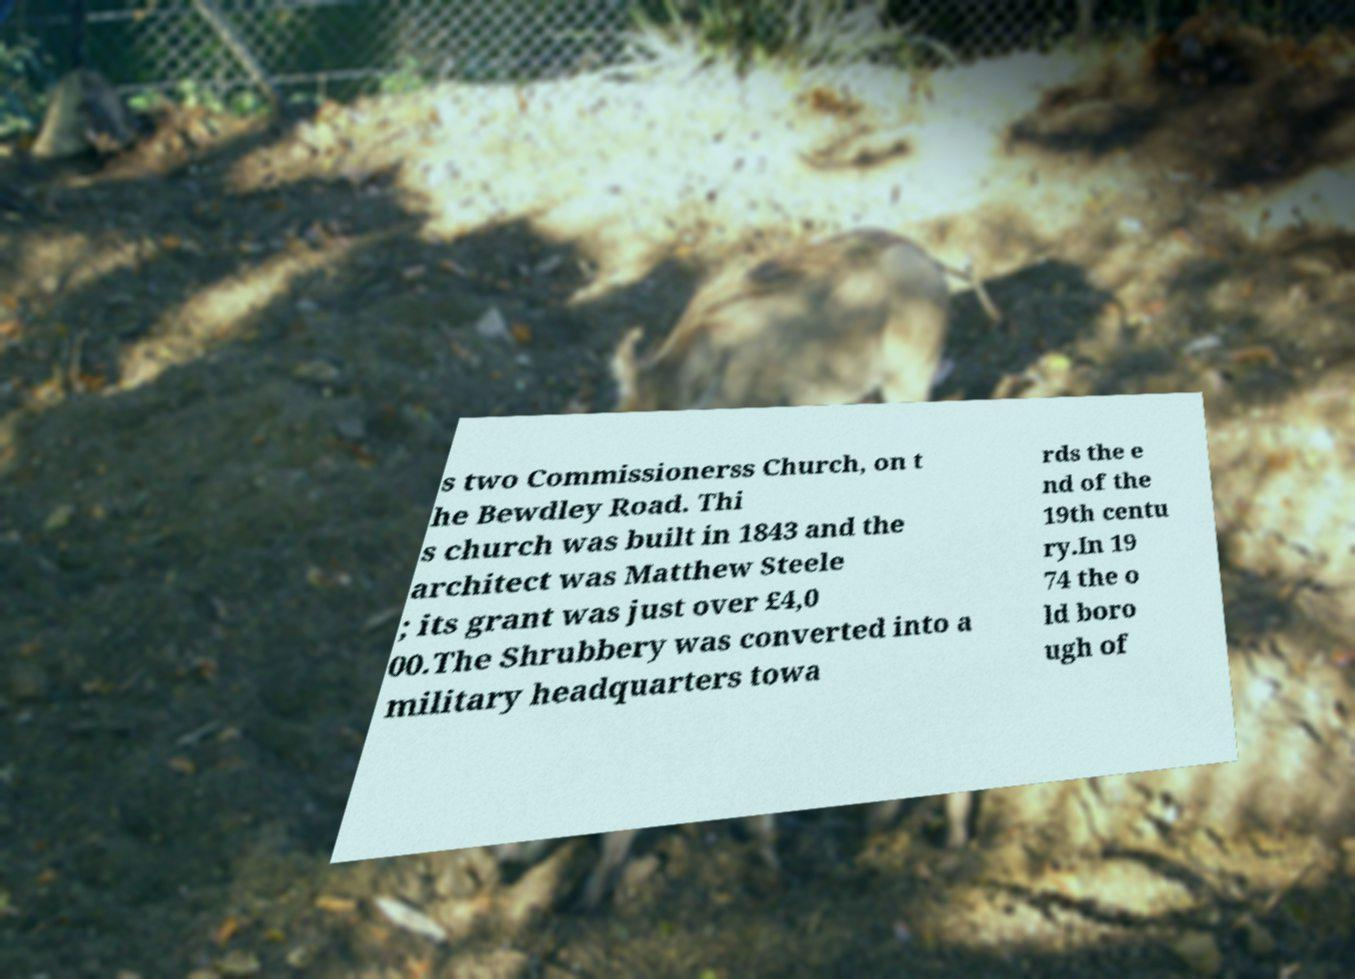Please read and relay the text visible in this image. What does it say? s two Commissionerss Church, on t he Bewdley Road. Thi s church was built in 1843 and the architect was Matthew Steele ; its grant was just over £4,0 00.The Shrubbery was converted into a military headquarters towa rds the e nd of the 19th centu ry.In 19 74 the o ld boro ugh of 